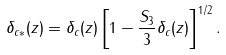<formula> <loc_0><loc_0><loc_500><loc_500>\delta _ { c * } ( z ) = \delta _ { c } ( z ) \left [ 1 - \frac { S _ { 3 } } { 3 } \delta _ { c } ( z ) \right ] ^ { 1 / 2 } .</formula> 